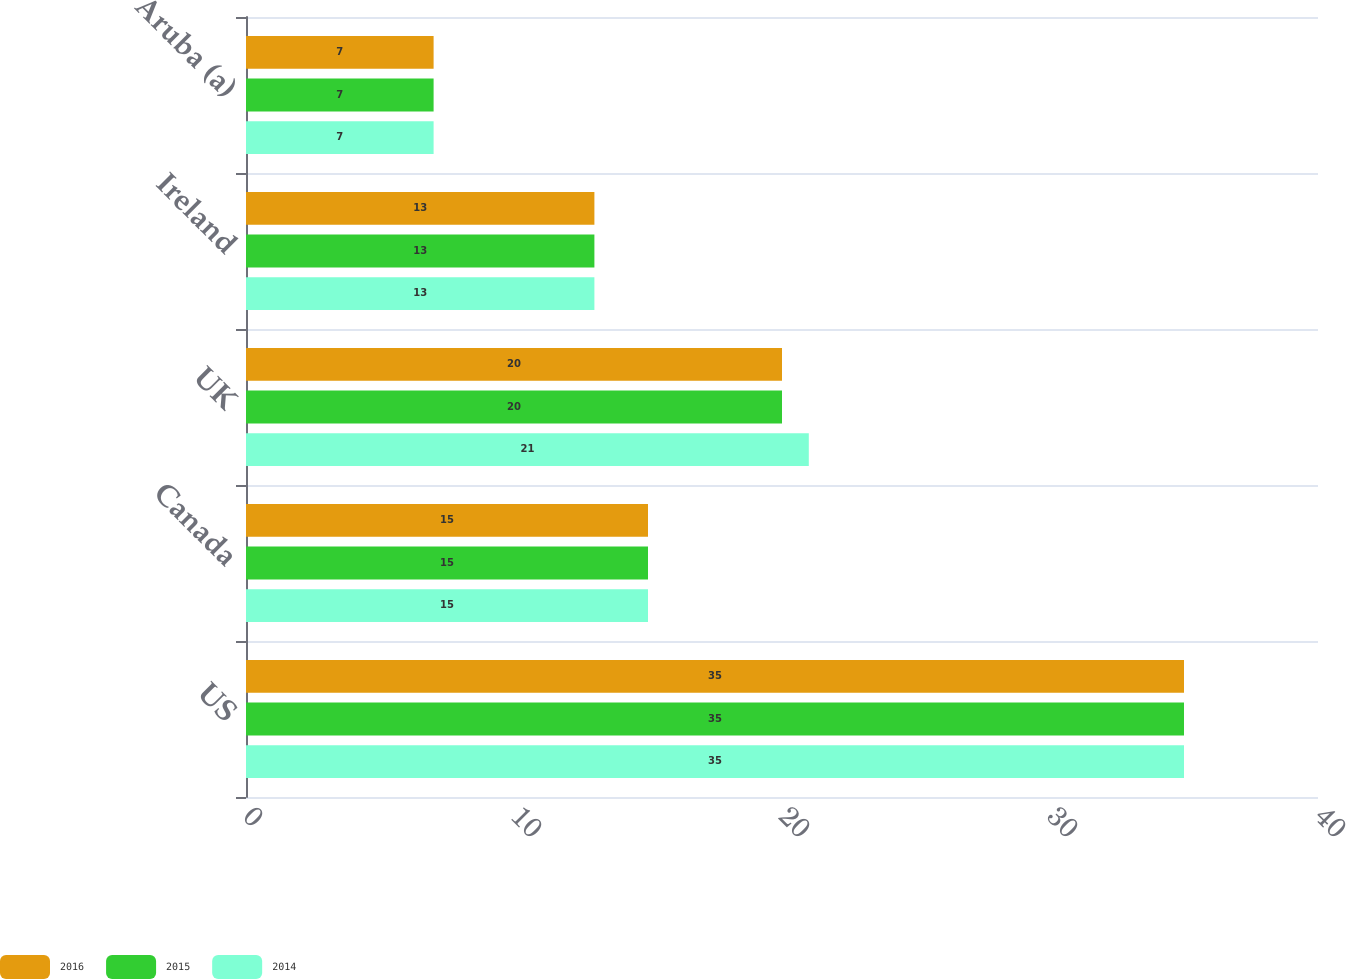Convert chart to OTSL. <chart><loc_0><loc_0><loc_500><loc_500><stacked_bar_chart><ecel><fcel>US<fcel>Canada<fcel>UK<fcel>Ireland<fcel>Aruba (a)<nl><fcel>2016<fcel>35<fcel>15<fcel>20<fcel>13<fcel>7<nl><fcel>2015<fcel>35<fcel>15<fcel>20<fcel>13<fcel>7<nl><fcel>2014<fcel>35<fcel>15<fcel>21<fcel>13<fcel>7<nl></chart> 